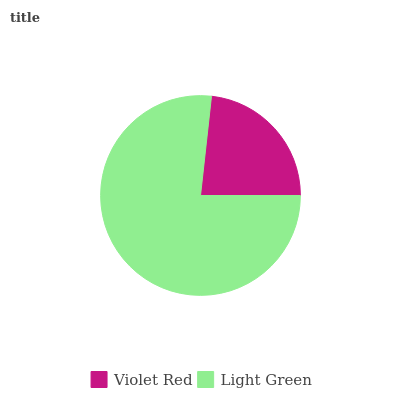Is Violet Red the minimum?
Answer yes or no. Yes. Is Light Green the maximum?
Answer yes or no. Yes. Is Light Green the minimum?
Answer yes or no. No. Is Light Green greater than Violet Red?
Answer yes or no. Yes. Is Violet Red less than Light Green?
Answer yes or no. Yes. Is Violet Red greater than Light Green?
Answer yes or no. No. Is Light Green less than Violet Red?
Answer yes or no. No. Is Light Green the high median?
Answer yes or no. Yes. Is Violet Red the low median?
Answer yes or no. Yes. Is Violet Red the high median?
Answer yes or no. No. Is Light Green the low median?
Answer yes or no. No. 